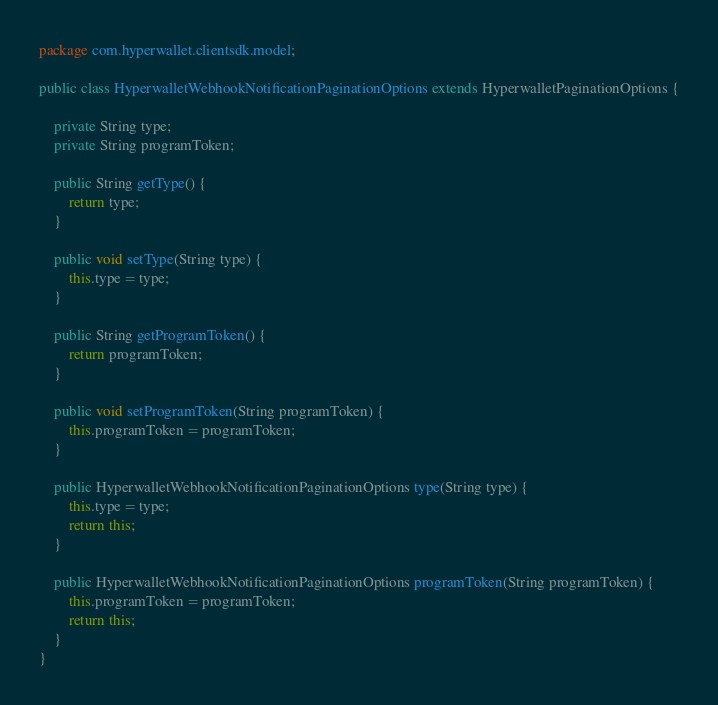Convert code to text. <code><loc_0><loc_0><loc_500><loc_500><_Java_>package com.hyperwallet.clientsdk.model;

public class HyperwalletWebhookNotificationPaginationOptions extends HyperwalletPaginationOptions {

    private String type;
    private String programToken;

    public String getType() {
        return type;
    }

    public void setType(String type) {
        this.type = type;
    }

    public String getProgramToken() {
        return programToken;
    }

    public void setProgramToken(String programToken) {
        this.programToken = programToken;
    }

    public HyperwalletWebhookNotificationPaginationOptions type(String type) {
        this.type = type;
        return this;
    }

    public HyperwalletWebhookNotificationPaginationOptions programToken(String programToken) {
        this.programToken = programToken;
        return this;
    }
}
</code> 